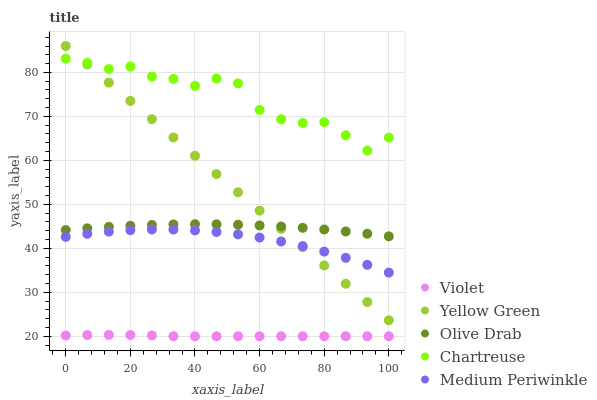Does Violet have the minimum area under the curve?
Answer yes or no. Yes. Does Chartreuse have the maximum area under the curve?
Answer yes or no. Yes. Does Medium Periwinkle have the minimum area under the curve?
Answer yes or no. No. Does Medium Periwinkle have the maximum area under the curve?
Answer yes or no. No. Is Yellow Green the smoothest?
Answer yes or no. Yes. Is Chartreuse the roughest?
Answer yes or no. Yes. Is Medium Periwinkle the smoothest?
Answer yes or no. No. Is Medium Periwinkle the roughest?
Answer yes or no. No. Does Violet have the lowest value?
Answer yes or no. Yes. Does Medium Periwinkle have the lowest value?
Answer yes or no. No. Does Yellow Green have the highest value?
Answer yes or no. Yes. Does Medium Periwinkle have the highest value?
Answer yes or no. No. Is Violet less than Yellow Green?
Answer yes or no. Yes. Is Olive Drab greater than Medium Periwinkle?
Answer yes or no. Yes. Does Chartreuse intersect Yellow Green?
Answer yes or no. Yes. Is Chartreuse less than Yellow Green?
Answer yes or no. No. Is Chartreuse greater than Yellow Green?
Answer yes or no. No. Does Violet intersect Yellow Green?
Answer yes or no. No. 